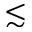Convert formula to latex. <formula><loc_0><loc_0><loc_500><loc_500>\lesssim</formula> 